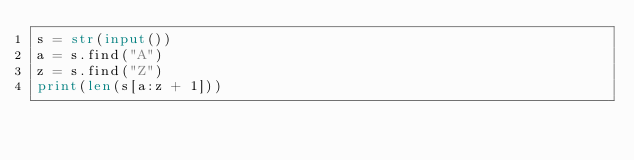<code> <loc_0><loc_0><loc_500><loc_500><_Python_>s = str(input())
a = s.find("A")
z = s.find("Z")
print(len(s[a:z + 1]))
</code> 